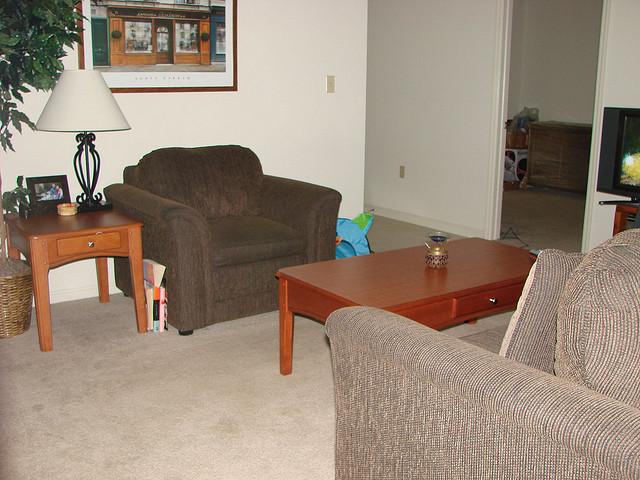How many chairs are there?
Quick response, please. 2. What is between the chair and table?
Write a very short answer. Books. What room is this?
Answer briefly. Living room. 